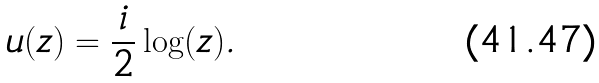<formula> <loc_0><loc_0><loc_500><loc_500>u ( z ) = \frac { i } { 2 } \log ( z ) .</formula> 